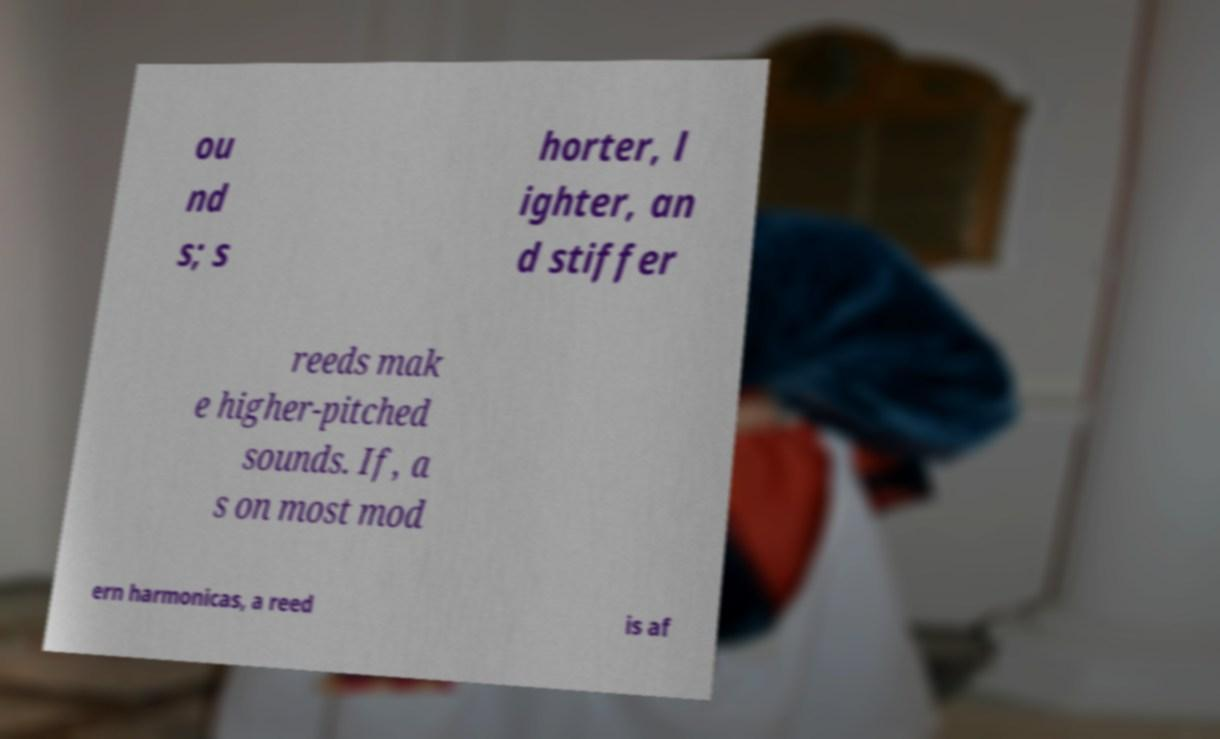What messages or text are displayed in this image? I need them in a readable, typed format. ou nd s; s horter, l ighter, an d stiffer reeds mak e higher-pitched sounds. If, a s on most mod ern harmonicas, a reed is af 